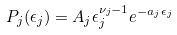<formula> <loc_0><loc_0><loc_500><loc_500>P _ { j } ( \epsilon _ { j } ) = A _ { j } \epsilon _ { j } ^ { \nu _ { j } - 1 } e ^ { - a _ { j } \epsilon _ { j } }</formula> 